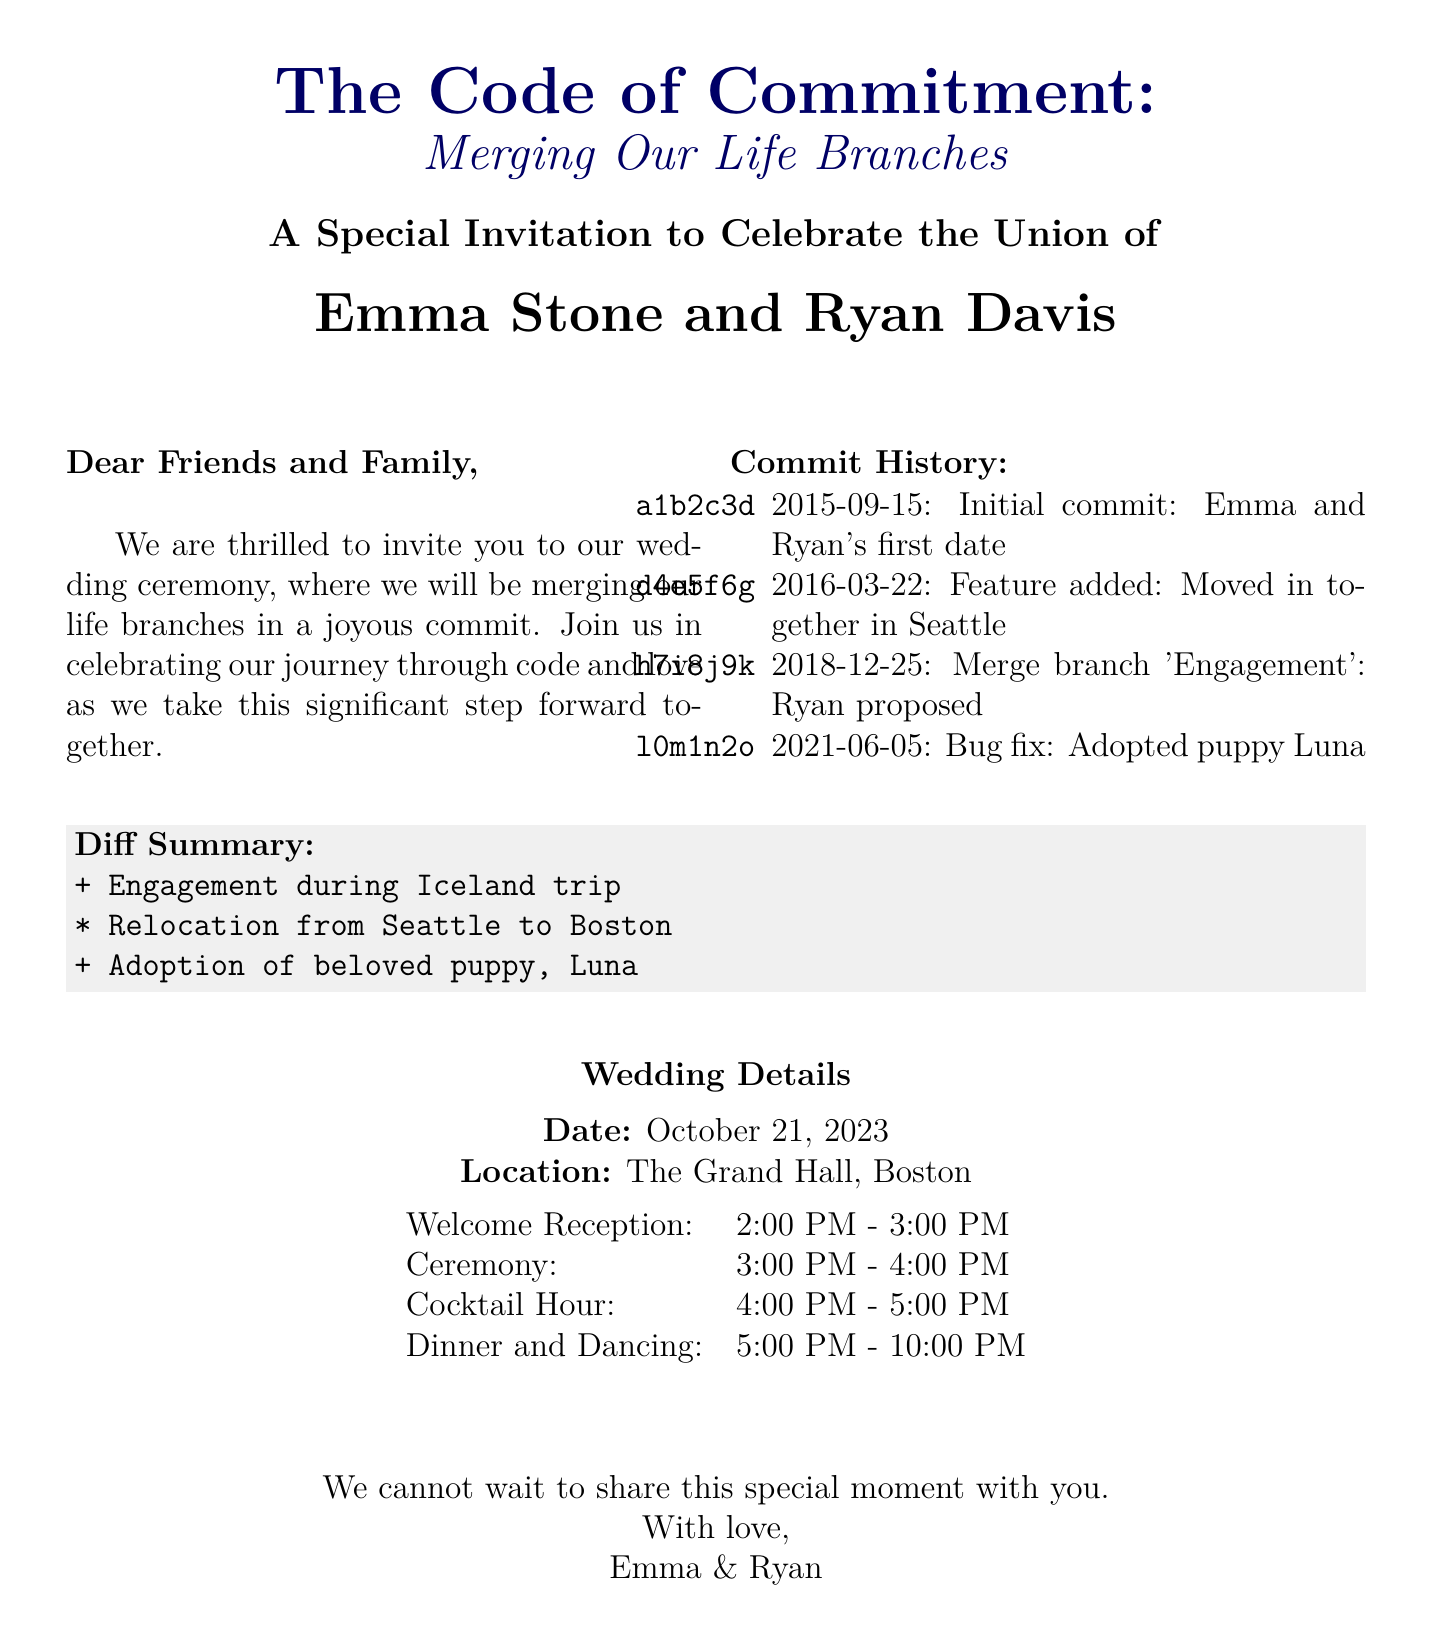What is the couple's name? The invitation clearly states the names of the couple getting married, which are Emma Stone and Ryan Davis.
Answer: Emma Stone and Ryan Davis What is the date of the wedding? The wedding date is explicitly mentioned in the details section of the invitation as October 21, 2023.
Answer: October 21, 2023 What is the location of the ceremony? The venue for the wedding ceremony is listed in the invitation, which is The Grand Hall, Boston.
Answer: The Grand Hall, Boston What was the first commit date in their history? The initial commit showcases their first date and is dated September 15, 2015.
Answer: September 15, 2015 What significant event was merged on December 25, 2018? The document mentions that on this date, Ryan proposed, marking a pivotal moment in their relationship.
Answer: Ryan proposed How long is the cocktail hour? This duration is specified alongside the wedding schedule, which states that the cocktail hour is one hour long.
Answer: 1 hour What special feature was added on June 5, 2021? The document indicates that a bug fix was made when they adopted their puppy, Luna.
Answer: Adopted puppy Luna What time does the ceremony start? The timing for the ceremony is clearly outlined, starting at 3:00 PM.
Answer: 3:00 PM What is the theme of the invitation? The overarching theme and title of the invitation reference merging life branches in the context of a version control system.
Answer: The Code of Commitment: Merging Our Life Branches 